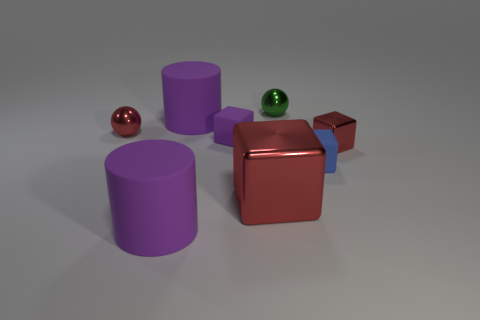Subtract all purple cylinders. How many red blocks are left? 2 Subtract all small blocks. How many blocks are left? 1 Add 1 metal balls. How many objects exist? 9 Subtract all purple blocks. How many blocks are left? 3 Subtract 2 blocks. How many blocks are left? 2 Subtract all balls. How many objects are left? 6 Subtract all yellow cubes. Subtract all brown cylinders. How many cubes are left? 4 Subtract 1 green balls. How many objects are left? 7 Subtract all small matte objects. Subtract all purple matte cubes. How many objects are left? 5 Add 2 large red metallic blocks. How many large red metallic blocks are left? 3 